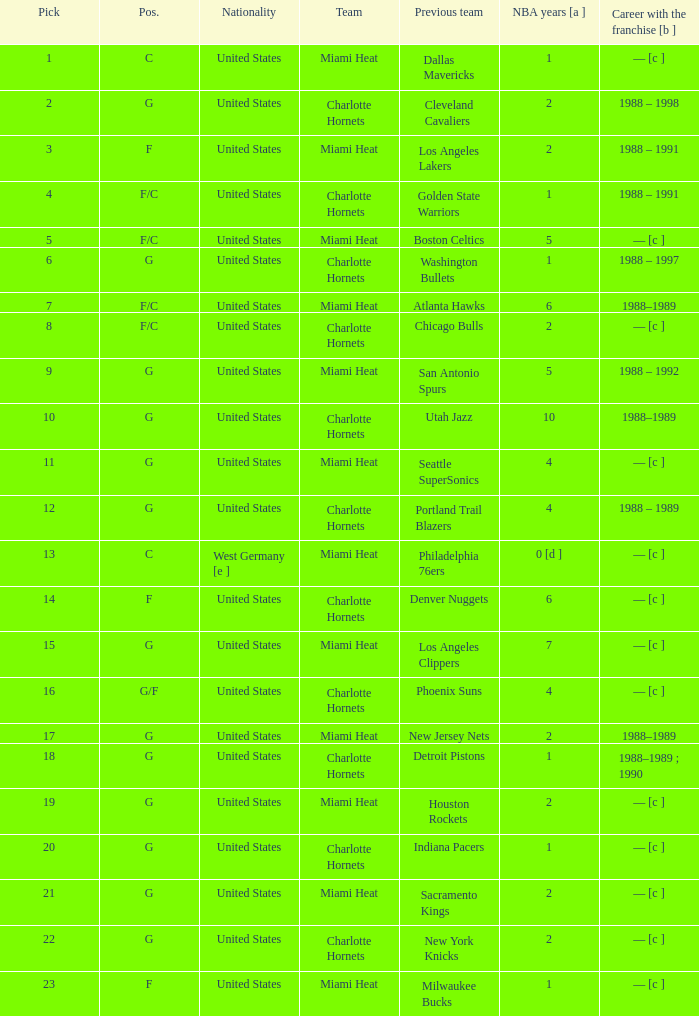What is the previous team of the player with 4 NBA years and a pick less than 16? Seattle SuperSonics, Portland Trail Blazers. 